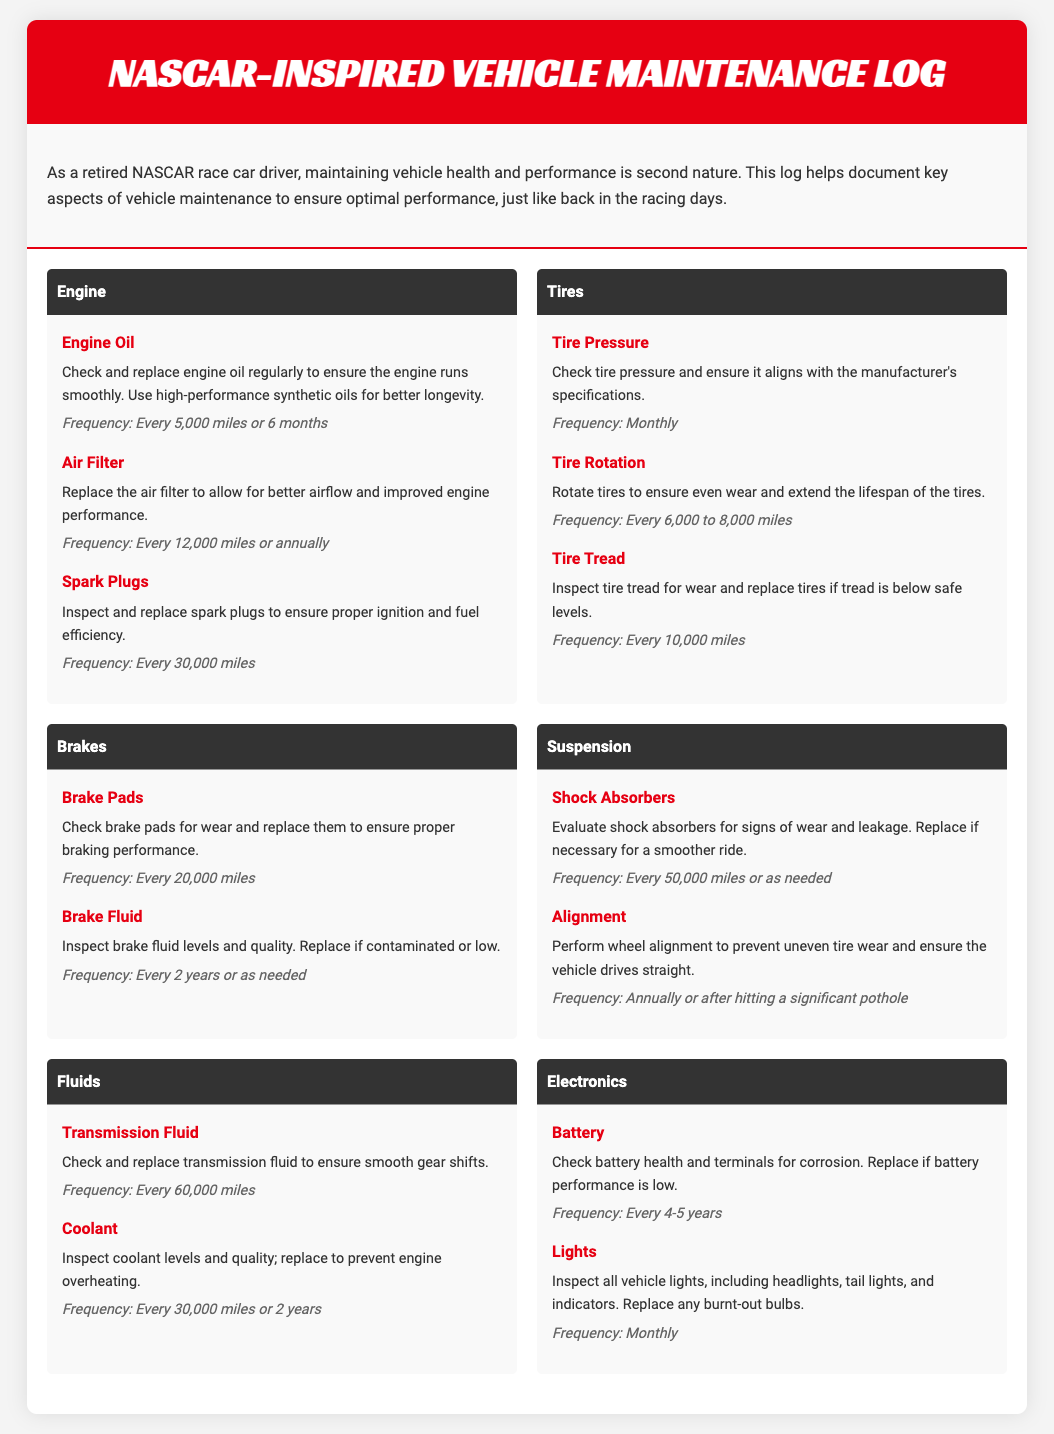what is the frequency for checking tire pressure? The frequency for checking tire pressure is mentioned in the Tires section.
Answer: Monthly how often should engine oil be replaced? The frequency for replacing engine oil is detailed in the Engine section.
Answer: Every 5,000 miles or 6 months what should be inspected every 10,000 miles? The item that should be inspected every 10,000 miles is listed under the Tires section.
Answer: Tire tread what is the recommended frequency for replacing brake pads? The frequency for replacing brake pads is provided in the Brakes section of the document.
Answer: Every 20,000 miles when should coolant be replaced? The replacement timing for coolant is outlined in the Fluids section.
Answer: Every 30,000 miles or 2 years how often should lights be inspected? The inspection frequency for lights is specified in the Electronics section.
Answer: Monthly how many miles before replacing spark plugs? The replacement mileage for spark plugs is given in the Engine section.
Answer: Every 30,000 miles what is the maintenance frequency for alignment? The maintenance frequency for alignment is in the Suspension section.
Answer: Annually or after hitting a significant pothole when should transmission fluid be replaced? The replacement timing for transmission fluid is mentioned in the Fluids section.
Answer: Every 60,000 miles 